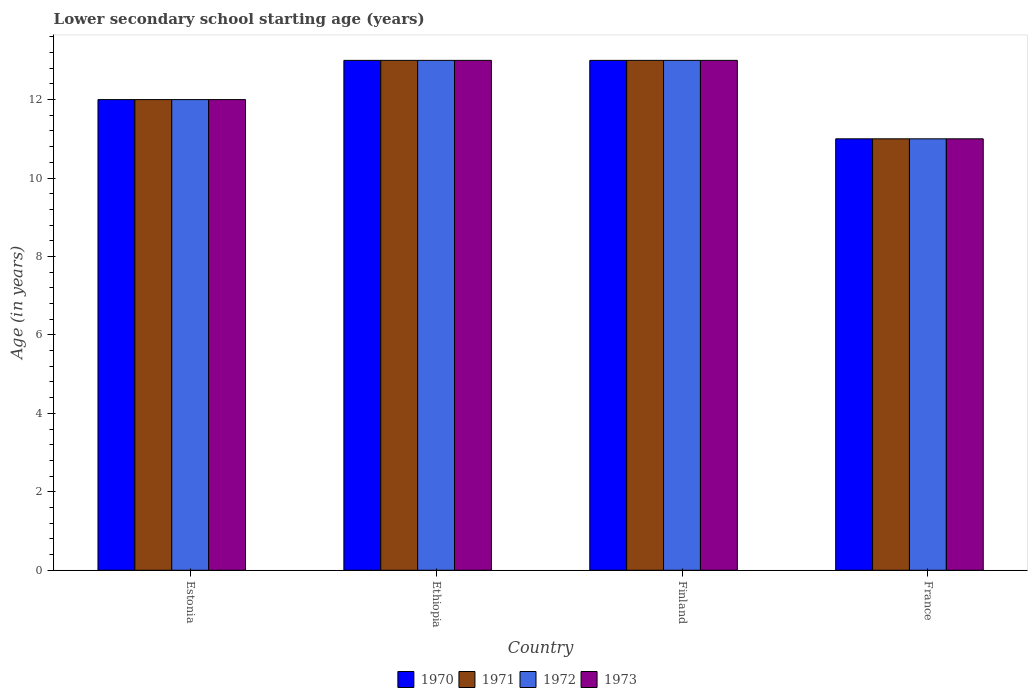How many different coloured bars are there?
Your response must be concise. 4. How many bars are there on the 2nd tick from the right?
Keep it short and to the point. 4. What is the lower secondary school starting age of children in 1973 in Estonia?
Offer a very short reply. 12. Across all countries, what is the maximum lower secondary school starting age of children in 1973?
Your answer should be compact. 13. In which country was the lower secondary school starting age of children in 1972 maximum?
Provide a succinct answer. Ethiopia. In which country was the lower secondary school starting age of children in 1970 minimum?
Your answer should be very brief. France. What is the total lower secondary school starting age of children in 1972 in the graph?
Your answer should be compact. 49. What is the difference between the lower secondary school starting age of children in 1970 in Estonia and the lower secondary school starting age of children in 1972 in Ethiopia?
Provide a succinct answer. -1. What is the average lower secondary school starting age of children in 1972 per country?
Your answer should be compact. 12.25. Is the difference between the lower secondary school starting age of children in 1972 in Ethiopia and Finland greater than the difference between the lower secondary school starting age of children in 1970 in Ethiopia and Finland?
Provide a short and direct response. No. What is the difference between the highest and the second highest lower secondary school starting age of children in 1973?
Keep it short and to the point. -1. In how many countries, is the lower secondary school starting age of children in 1971 greater than the average lower secondary school starting age of children in 1971 taken over all countries?
Give a very brief answer. 2. Is the sum of the lower secondary school starting age of children in 1973 in Finland and France greater than the maximum lower secondary school starting age of children in 1972 across all countries?
Offer a very short reply. Yes. How many bars are there?
Offer a terse response. 16. What is the difference between two consecutive major ticks on the Y-axis?
Provide a short and direct response. 2. How are the legend labels stacked?
Provide a short and direct response. Horizontal. What is the title of the graph?
Your answer should be compact. Lower secondary school starting age (years). Does "1974" appear as one of the legend labels in the graph?
Offer a terse response. No. What is the label or title of the Y-axis?
Your answer should be compact. Age (in years). What is the Age (in years) in 1971 in Estonia?
Provide a succinct answer. 12. What is the Age (in years) of 1973 in Estonia?
Your answer should be very brief. 12. What is the Age (in years) of 1972 in Finland?
Your answer should be compact. 13. What is the Age (in years) in 1970 in France?
Your answer should be very brief. 11. What is the Age (in years) of 1971 in France?
Your response must be concise. 11. What is the Age (in years) of 1972 in France?
Offer a terse response. 11. Across all countries, what is the maximum Age (in years) of 1970?
Provide a short and direct response. 13. Across all countries, what is the maximum Age (in years) of 1973?
Provide a succinct answer. 13. Across all countries, what is the minimum Age (in years) in 1971?
Offer a very short reply. 11. What is the total Age (in years) in 1970 in the graph?
Give a very brief answer. 49. What is the total Age (in years) of 1972 in the graph?
Keep it short and to the point. 49. What is the total Age (in years) in 1973 in the graph?
Your answer should be very brief. 49. What is the difference between the Age (in years) of 1970 in Estonia and that in Ethiopia?
Your answer should be compact. -1. What is the difference between the Age (in years) of 1972 in Estonia and that in Ethiopia?
Your response must be concise. -1. What is the difference between the Age (in years) in 1970 in Estonia and that in Finland?
Give a very brief answer. -1. What is the difference between the Age (in years) of 1971 in Estonia and that in Finland?
Ensure brevity in your answer.  -1. What is the difference between the Age (in years) of 1972 in Estonia and that in Finland?
Provide a succinct answer. -1. What is the difference between the Age (in years) in 1973 in Estonia and that in Finland?
Offer a very short reply. -1. What is the difference between the Age (in years) in 1970 in Estonia and that in France?
Ensure brevity in your answer.  1. What is the difference between the Age (in years) of 1971 in Estonia and that in France?
Offer a very short reply. 1. What is the difference between the Age (in years) of 1972 in Estonia and that in France?
Give a very brief answer. 1. What is the difference between the Age (in years) in 1970 in Ethiopia and that in France?
Keep it short and to the point. 2. What is the difference between the Age (in years) in 1972 in Ethiopia and that in France?
Your answer should be very brief. 2. What is the difference between the Age (in years) in 1971 in Finland and that in France?
Give a very brief answer. 2. What is the difference between the Age (in years) of 1972 in Finland and that in France?
Give a very brief answer. 2. What is the difference between the Age (in years) of 1970 in Estonia and the Age (in years) of 1971 in Ethiopia?
Provide a succinct answer. -1. What is the difference between the Age (in years) in 1970 in Estonia and the Age (in years) in 1972 in Ethiopia?
Give a very brief answer. -1. What is the difference between the Age (in years) in 1970 in Estonia and the Age (in years) in 1973 in Ethiopia?
Provide a succinct answer. -1. What is the difference between the Age (in years) in 1971 in Estonia and the Age (in years) in 1972 in Ethiopia?
Provide a succinct answer. -1. What is the difference between the Age (in years) of 1971 in Estonia and the Age (in years) of 1973 in Ethiopia?
Keep it short and to the point. -1. What is the difference between the Age (in years) in 1972 in Estonia and the Age (in years) in 1973 in Ethiopia?
Your answer should be very brief. -1. What is the difference between the Age (in years) in 1970 in Estonia and the Age (in years) in 1971 in Finland?
Keep it short and to the point. -1. What is the difference between the Age (in years) in 1970 in Estonia and the Age (in years) in 1972 in Finland?
Provide a succinct answer. -1. What is the difference between the Age (in years) in 1971 in Estonia and the Age (in years) in 1972 in Finland?
Provide a succinct answer. -1. What is the difference between the Age (in years) in 1971 in Estonia and the Age (in years) in 1973 in Finland?
Give a very brief answer. -1. What is the difference between the Age (in years) in 1970 in Estonia and the Age (in years) in 1972 in France?
Your answer should be compact. 1. What is the difference between the Age (in years) of 1970 in Estonia and the Age (in years) of 1973 in France?
Make the answer very short. 1. What is the difference between the Age (in years) of 1971 in Estonia and the Age (in years) of 1973 in France?
Give a very brief answer. 1. What is the difference between the Age (in years) in 1970 in Ethiopia and the Age (in years) in 1971 in Finland?
Offer a very short reply. 0. What is the difference between the Age (in years) of 1970 in Ethiopia and the Age (in years) of 1973 in Finland?
Provide a succinct answer. 0. What is the difference between the Age (in years) in 1971 in Ethiopia and the Age (in years) in 1972 in Finland?
Provide a short and direct response. 0. What is the difference between the Age (in years) in 1971 in Ethiopia and the Age (in years) in 1973 in Finland?
Keep it short and to the point. 0. What is the difference between the Age (in years) in 1970 in Ethiopia and the Age (in years) in 1971 in France?
Provide a succinct answer. 2. What is the difference between the Age (in years) of 1970 in Ethiopia and the Age (in years) of 1973 in France?
Make the answer very short. 2. What is the difference between the Age (in years) of 1972 in Ethiopia and the Age (in years) of 1973 in France?
Provide a succinct answer. 2. What is the difference between the Age (in years) in 1970 in Finland and the Age (in years) in 1971 in France?
Ensure brevity in your answer.  2. What is the difference between the Age (in years) of 1970 in Finland and the Age (in years) of 1973 in France?
Ensure brevity in your answer.  2. What is the difference between the Age (in years) of 1972 in Finland and the Age (in years) of 1973 in France?
Keep it short and to the point. 2. What is the average Age (in years) in 1970 per country?
Your response must be concise. 12.25. What is the average Age (in years) in 1971 per country?
Provide a succinct answer. 12.25. What is the average Age (in years) of 1972 per country?
Make the answer very short. 12.25. What is the average Age (in years) of 1973 per country?
Provide a succinct answer. 12.25. What is the difference between the Age (in years) of 1970 and Age (in years) of 1972 in Ethiopia?
Provide a succinct answer. 0. What is the difference between the Age (in years) in 1971 and Age (in years) in 1972 in Ethiopia?
Your answer should be very brief. 0. What is the difference between the Age (in years) in 1971 and Age (in years) in 1973 in Ethiopia?
Your response must be concise. 0. What is the difference between the Age (in years) of 1972 and Age (in years) of 1973 in Ethiopia?
Your answer should be very brief. 0. What is the difference between the Age (in years) of 1971 and Age (in years) of 1973 in Finland?
Make the answer very short. 0. What is the difference between the Age (in years) of 1970 and Age (in years) of 1972 in France?
Offer a terse response. 0. What is the difference between the Age (in years) of 1970 and Age (in years) of 1973 in France?
Your response must be concise. 0. What is the ratio of the Age (in years) of 1970 in Estonia to that in Ethiopia?
Provide a succinct answer. 0.92. What is the ratio of the Age (in years) of 1973 in Estonia to that in Ethiopia?
Ensure brevity in your answer.  0.92. What is the ratio of the Age (in years) in 1971 in Estonia to that in Finland?
Give a very brief answer. 0.92. What is the ratio of the Age (in years) of 1973 in Estonia to that in Finland?
Provide a short and direct response. 0.92. What is the ratio of the Age (in years) of 1970 in Estonia to that in France?
Provide a succinct answer. 1.09. What is the ratio of the Age (in years) in 1970 in Ethiopia to that in Finland?
Your answer should be compact. 1. What is the ratio of the Age (in years) in 1970 in Ethiopia to that in France?
Your answer should be very brief. 1.18. What is the ratio of the Age (in years) in 1971 in Ethiopia to that in France?
Provide a succinct answer. 1.18. What is the ratio of the Age (in years) in 1972 in Ethiopia to that in France?
Provide a succinct answer. 1.18. What is the ratio of the Age (in years) in 1973 in Ethiopia to that in France?
Your response must be concise. 1.18. What is the ratio of the Age (in years) of 1970 in Finland to that in France?
Give a very brief answer. 1.18. What is the ratio of the Age (in years) of 1971 in Finland to that in France?
Offer a terse response. 1.18. What is the ratio of the Age (in years) of 1972 in Finland to that in France?
Provide a short and direct response. 1.18. What is the ratio of the Age (in years) of 1973 in Finland to that in France?
Offer a very short reply. 1.18. What is the difference between the highest and the second highest Age (in years) in 1971?
Ensure brevity in your answer.  0. What is the difference between the highest and the lowest Age (in years) of 1971?
Offer a terse response. 2. What is the difference between the highest and the lowest Age (in years) of 1973?
Keep it short and to the point. 2. 